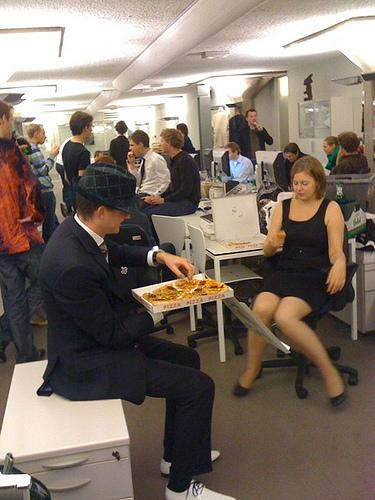Where are people here eating pizza today? office 